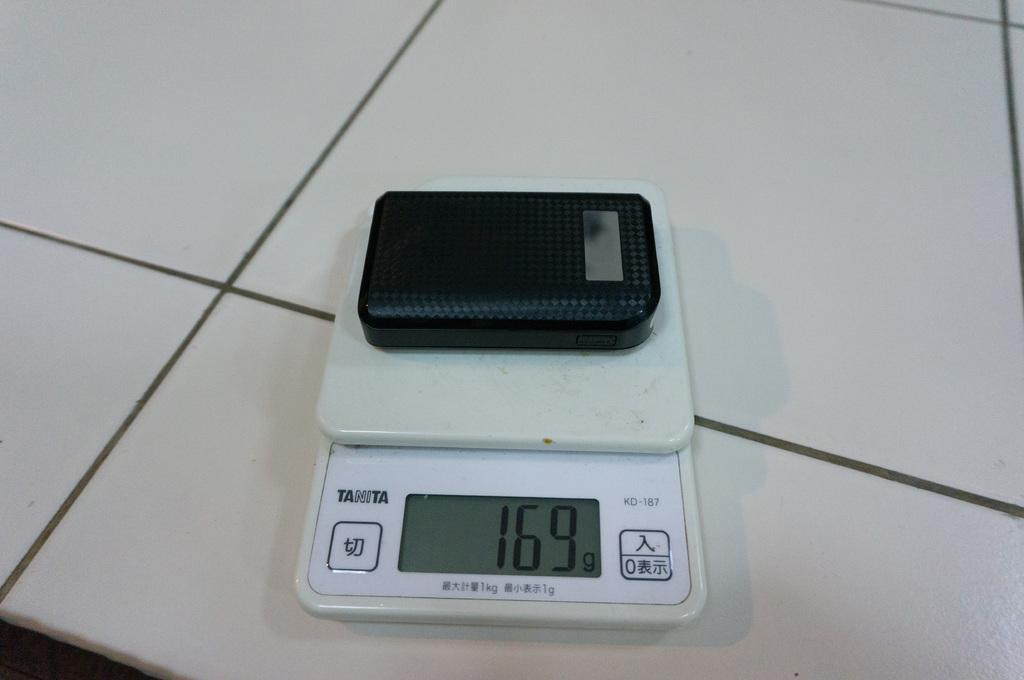<image>
Provide a brief description of the given image. A black box is being weighed on a Tanita brand scale. 